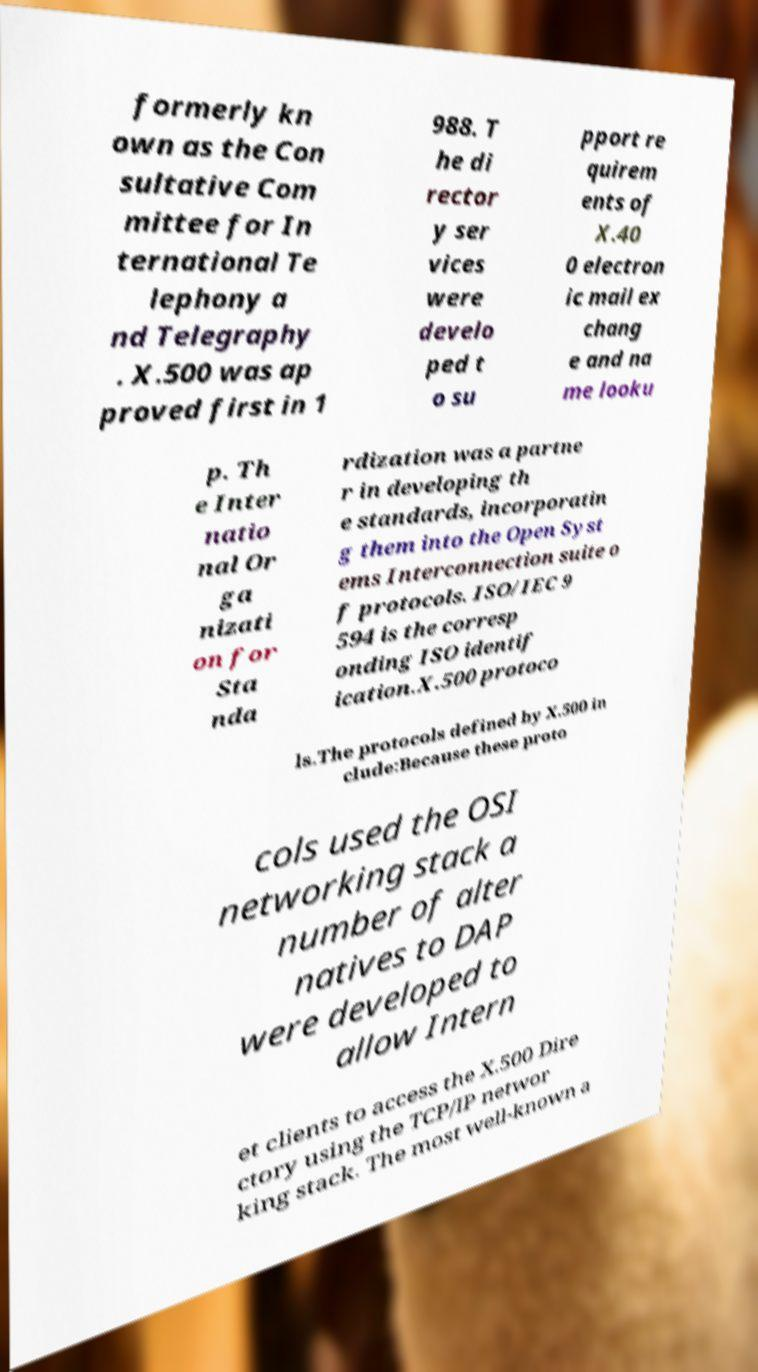I need the written content from this picture converted into text. Can you do that? formerly kn own as the Con sultative Com mittee for In ternational Te lephony a nd Telegraphy . X.500 was ap proved first in 1 988. T he di rector y ser vices were develo ped t o su pport re quirem ents of X.40 0 electron ic mail ex chang e and na me looku p. Th e Inter natio nal Or ga nizati on for Sta nda rdization was a partne r in developing th e standards, incorporatin g them into the Open Syst ems Interconnection suite o f protocols. ISO/IEC 9 594 is the corresp onding ISO identif ication.X.500 protoco ls.The protocols defined by X.500 in clude:Because these proto cols used the OSI networking stack a number of alter natives to DAP were developed to allow Intern et clients to access the X.500 Dire ctory using the TCP/IP networ king stack. The most well-known a 